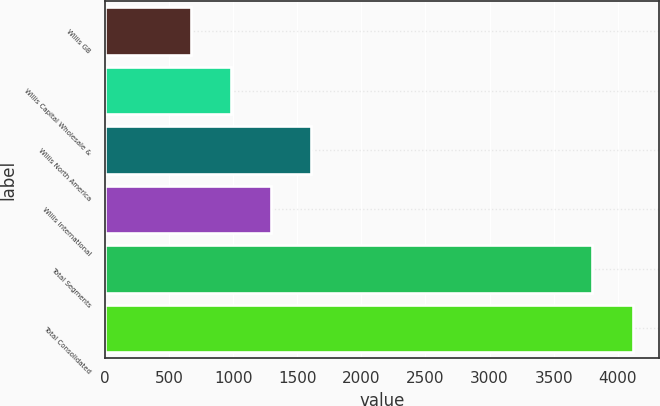<chart> <loc_0><loc_0><loc_500><loc_500><bar_chart><fcel>Willis GB<fcel>Willis Capital Wholesale &<fcel>Willis North America<fcel>Willis International<fcel>Total Segments<fcel>Total Consolidated<nl><fcel>669<fcel>982.3<fcel>1608.9<fcel>1295.6<fcel>3802<fcel>4115.3<nl></chart> 